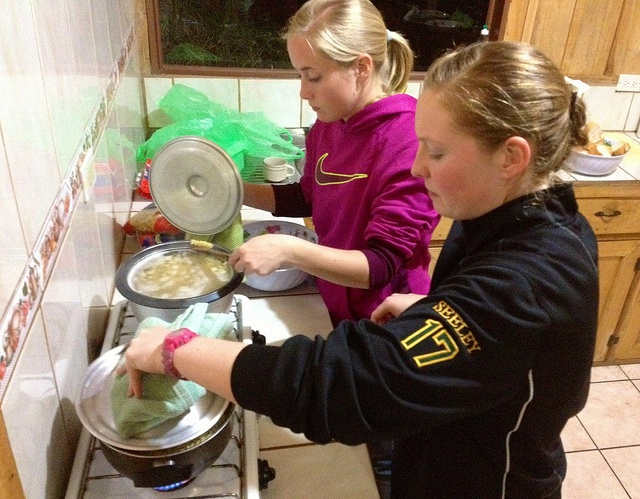Describe the objects in this image and their specific colors. I can see people in beige, black, gray, and maroon tones, people in beige, maroon, gray, purple, and black tones, oven in beige, gray, darkgray, and black tones, bowl in beige, gray, darkgray, and maroon tones, and bowl in beige, lightgray, and darkgray tones in this image. 